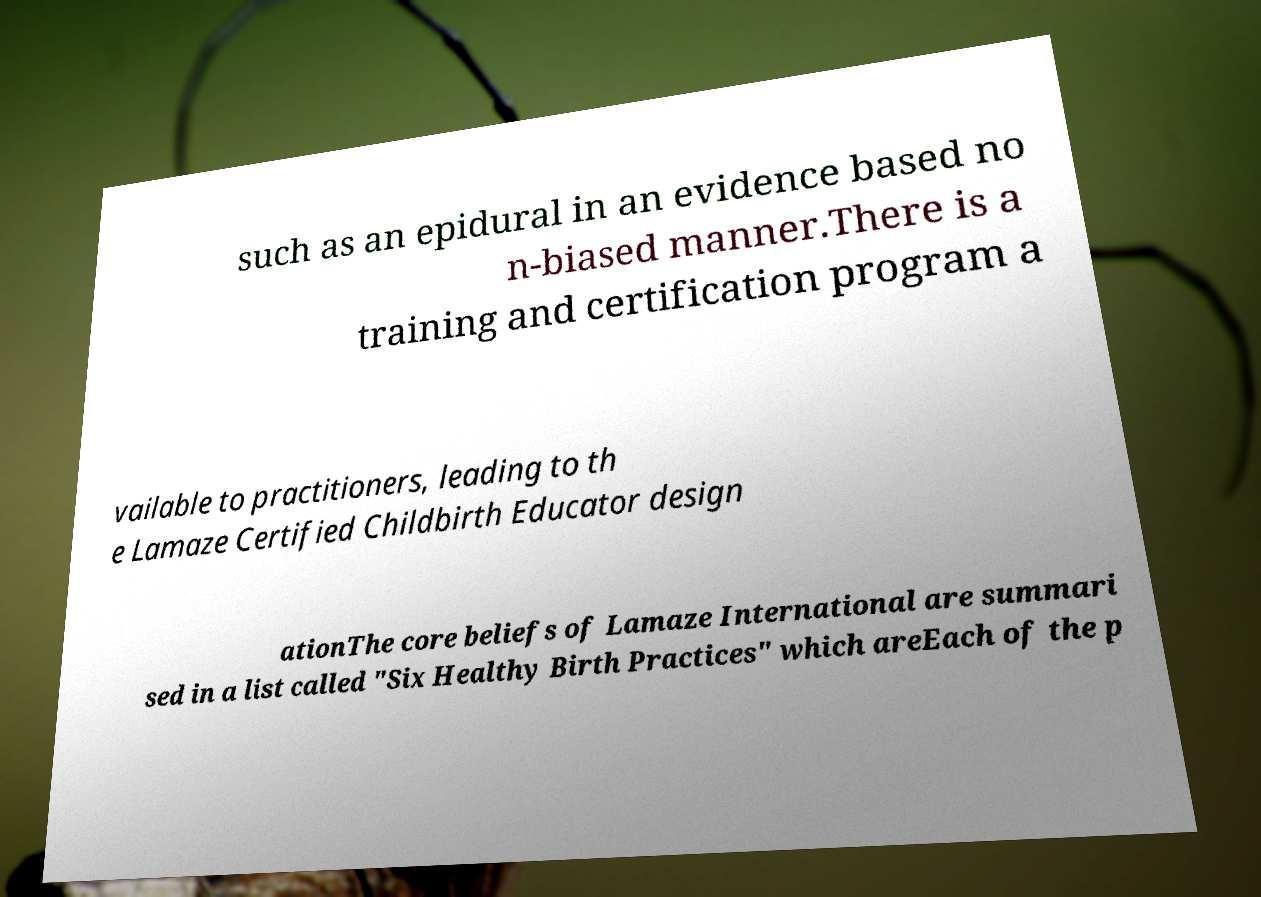Can you accurately transcribe the text from the provided image for me? such as an epidural in an evidence based no n-biased manner.There is a training and certification program a vailable to practitioners, leading to th e Lamaze Certified Childbirth Educator design ationThe core beliefs of Lamaze International are summari sed in a list called "Six Healthy Birth Practices" which areEach of the p 